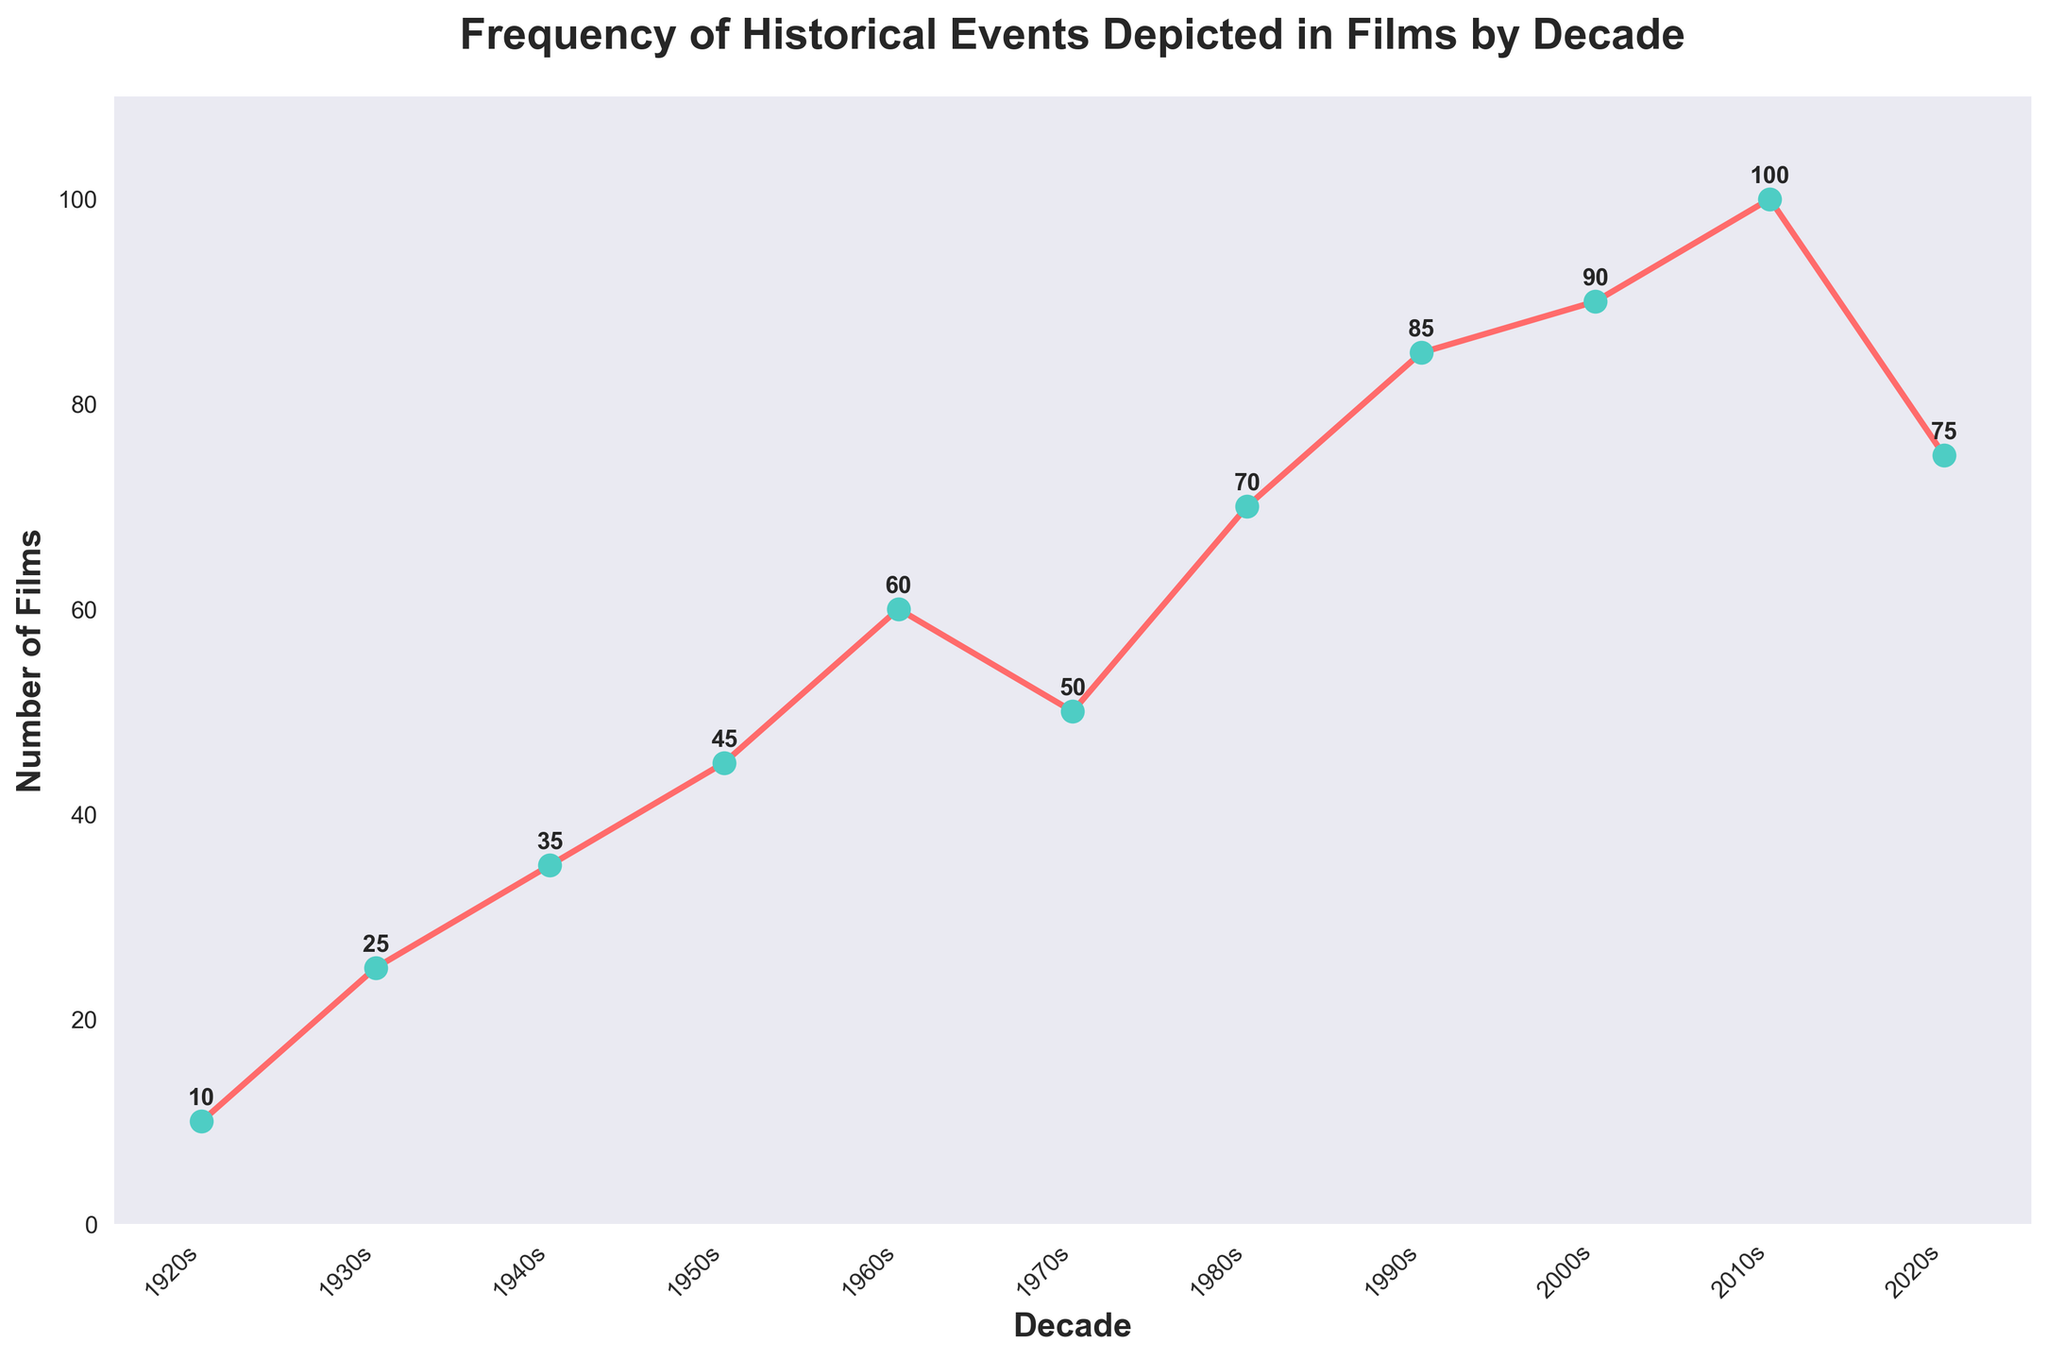What's the title of the figure? The title is located at the top of the figure and reads, "Frequency of Historical Events Depicted in Films by Decade."
Answer: Frequency of Historical Events Depicted in Films by Decade How many decades are represented in the figure? The x-axis displays the decades depicted in the figure, ranging from the 1920s to the 2020s. Counting each tick mark, we find there are 11 decades represented.
Answer: 11 Which decade had the highest number of films depicting historical events? Looking at the y-axis values, the 2010s had the highest number as indicated by the peak point reaching 100.
Answer: 2010s What's the difference in the number of films between the 2010s and the 1920s? The 2010s had 100 films, and the 1920s had 10 films. The difference is calculated as 100 - 10.
Answer: 90 In which decade did the number of films first surpass 50? We can see from the y-axis values and the plot points that the number of films first surpassed 50 in the 1960s.
Answer: 1960s Compare the number of films in the 1970s to the 2020s. Which decade had more? The y-axis values show that the 2020s had 75 films while the 1970s had 50 films. Therefore, the 2020s had more films.
Answer: 2020s What’s the average number of films depicting historical events per decade? Adding the number of films for each decade and dividing by 11 (the number of decades): (10 + 25 + 35 + 45 + 60 + 50 + 70 + 85 + 90 + 100 + 75) / 11 = 64.09.
Answer: 64.09 In which decade(s) did the number of films decrease compared to the previous decade? Comparing consecutive decades: The 1970s (50) decreased from the 1960s (60) and the 2020s (75) decreased from the 2010s (100).
Answer: 1970s, 2020s By how many films did the number increase between the 1990s and the 2000s? The 2000s had 90 films and the 1990s had 85 films. The increase is 90 - 85.
Answer: 5 What trend is visible from the 1940s to the 2010s? From the 1940s to the 2010s, the plot shows an overall increasing trend in the number of films depicting historical events, reaching a peak in the 2010s.
Answer: Increasing trend 